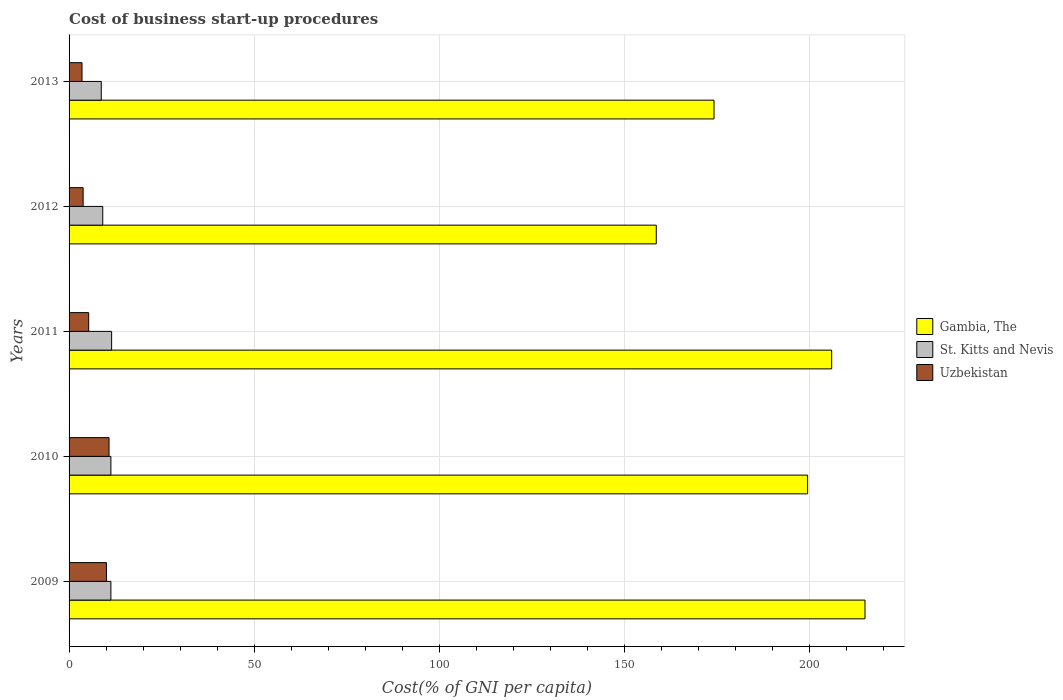How many different coloured bars are there?
Offer a terse response. 3. How many bars are there on the 1st tick from the top?
Offer a very short reply. 3. In how many cases, is the number of bars for a given year not equal to the number of legend labels?
Provide a succinct answer. 0. What is the cost of business start-up procedures in St. Kitts and Nevis in 2013?
Offer a very short reply. 8.7. Across all years, what is the maximum cost of business start-up procedures in Uzbekistan?
Give a very brief answer. 10.8. What is the total cost of business start-up procedures in Uzbekistan in the graph?
Ensure brevity in your answer.  33.5. What is the difference between the cost of business start-up procedures in Uzbekistan in 2009 and that in 2013?
Give a very brief answer. 6.6. What is the difference between the cost of business start-up procedures in Uzbekistan in 2011 and the cost of business start-up procedures in Gambia, The in 2012?
Ensure brevity in your answer.  -153.4. What is the ratio of the cost of business start-up procedures in Gambia, The in 2009 to that in 2010?
Your answer should be compact. 1.08. What is the difference between the highest and the second highest cost of business start-up procedures in Uzbekistan?
Your response must be concise. 0.7. What is the difference between the highest and the lowest cost of business start-up procedures in Uzbekistan?
Provide a succinct answer. 7.3. What does the 3rd bar from the top in 2009 represents?
Offer a very short reply. Gambia, The. What does the 1st bar from the bottom in 2011 represents?
Your response must be concise. Gambia, The. Is it the case that in every year, the sum of the cost of business start-up procedures in St. Kitts and Nevis and cost of business start-up procedures in Gambia, The is greater than the cost of business start-up procedures in Uzbekistan?
Offer a very short reply. Yes. How many bars are there?
Your answer should be compact. 15. What is the difference between two consecutive major ticks on the X-axis?
Make the answer very short. 50. Are the values on the major ticks of X-axis written in scientific E-notation?
Ensure brevity in your answer.  No. Does the graph contain grids?
Offer a terse response. Yes. Where does the legend appear in the graph?
Offer a very short reply. Center right. What is the title of the graph?
Offer a terse response. Cost of business start-up procedures. Does "High income: OECD" appear as one of the legend labels in the graph?
Your answer should be compact. No. What is the label or title of the X-axis?
Make the answer very short. Cost(% of GNI per capita). What is the Cost(% of GNI per capita) in Gambia, The in 2009?
Provide a short and direct response. 215.1. What is the Cost(% of GNI per capita) of St. Kitts and Nevis in 2009?
Your answer should be compact. 11.3. What is the Cost(% of GNI per capita) in Uzbekistan in 2009?
Provide a short and direct response. 10.1. What is the Cost(% of GNI per capita) in Gambia, The in 2010?
Offer a very short reply. 199.6. What is the Cost(% of GNI per capita) in St. Kitts and Nevis in 2010?
Provide a short and direct response. 11.3. What is the Cost(% of GNI per capita) of Uzbekistan in 2010?
Keep it short and to the point. 10.8. What is the Cost(% of GNI per capita) in Gambia, The in 2011?
Offer a terse response. 206.1. What is the Cost(% of GNI per capita) in Gambia, The in 2012?
Make the answer very short. 158.7. What is the Cost(% of GNI per capita) of St. Kitts and Nevis in 2012?
Provide a short and direct response. 9.1. What is the Cost(% of GNI per capita) of Uzbekistan in 2012?
Your response must be concise. 3.8. What is the Cost(% of GNI per capita) of Gambia, The in 2013?
Provide a short and direct response. 174.3. What is the Cost(% of GNI per capita) of St. Kitts and Nevis in 2013?
Provide a short and direct response. 8.7. What is the Cost(% of GNI per capita) in Uzbekistan in 2013?
Provide a short and direct response. 3.5. Across all years, what is the maximum Cost(% of GNI per capita) of Gambia, The?
Provide a short and direct response. 215.1. Across all years, what is the maximum Cost(% of GNI per capita) of St. Kitts and Nevis?
Ensure brevity in your answer.  11.5. Across all years, what is the maximum Cost(% of GNI per capita) in Uzbekistan?
Offer a very short reply. 10.8. Across all years, what is the minimum Cost(% of GNI per capita) of Gambia, The?
Your answer should be very brief. 158.7. Across all years, what is the minimum Cost(% of GNI per capita) in St. Kitts and Nevis?
Make the answer very short. 8.7. Across all years, what is the minimum Cost(% of GNI per capita) in Uzbekistan?
Your answer should be very brief. 3.5. What is the total Cost(% of GNI per capita) in Gambia, The in the graph?
Keep it short and to the point. 953.8. What is the total Cost(% of GNI per capita) in St. Kitts and Nevis in the graph?
Provide a succinct answer. 51.9. What is the total Cost(% of GNI per capita) in Uzbekistan in the graph?
Offer a terse response. 33.5. What is the difference between the Cost(% of GNI per capita) in Gambia, The in 2009 and that in 2010?
Your answer should be very brief. 15.5. What is the difference between the Cost(% of GNI per capita) in St. Kitts and Nevis in 2009 and that in 2010?
Offer a very short reply. 0. What is the difference between the Cost(% of GNI per capita) of St. Kitts and Nevis in 2009 and that in 2011?
Provide a succinct answer. -0.2. What is the difference between the Cost(% of GNI per capita) of Gambia, The in 2009 and that in 2012?
Give a very brief answer. 56.4. What is the difference between the Cost(% of GNI per capita) of St. Kitts and Nevis in 2009 and that in 2012?
Keep it short and to the point. 2.2. What is the difference between the Cost(% of GNI per capita) of Uzbekistan in 2009 and that in 2012?
Keep it short and to the point. 6.3. What is the difference between the Cost(% of GNI per capita) in Gambia, The in 2009 and that in 2013?
Make the answer very short. 40.8. What is the difference between the Cost(% of GNI per capita) of St. Kitts and Nevis in 2010 and that in 2011?
Ensure brevity in your answer.  -0.2. What is the difference between the Cost(% of GNI per capita) in Uzbekistan in 2010 and that in 2011?
Keep it short and to the point. 5.5. What is the difference between the Cost(% of GNI per capita) of Gambia, The in 2010 and that in 2012?
Offer a very short reply. 40.9. What is the difference between the Cost(% of GNI per capita) of Uzbekistan in 2010 and that in 2012?
Your response must be concise. 7. What is the difference between the Cost(% of GNI per capita) in Gambia, The in 2010 and that in 2013?
Your answer should be compact. 25.3. What is the difference between the Cost(% of GNI per capita) in Gambia, The in 2011 and that in 2012?
Give a very brief answer. 47.4. What is the difference between the Cost(% of GNI per capita) in St. Kitts and Nevis in 2011 and that in 2012?
Your answer should be compact. 2.4. What is the difference between the Cost(% of GNI per capita) of Uzbekistan in 2011 and that in 2012?
Offer a very short reply. 1.5. What is the difference between the Cost(% of GNI per capita) in Gambia, The in 2011 and that in 2013?
Make the answer very short. 31.8. What is the difference between the Cost(% of GNI per capita) in Gambia, The in 2012 and that in 2013?
Provide a succinct answer. -15.6. What is the difference between the Cost(% of GNI per capita) of Gambia, The in 2009 and the Cost(% of GNI per capita) of St. Kitts and Nevis in 2010?
Provide a succinct answer. 203.8. What is the difference between the Cost(% of GNI per capita) in Gambia, The in 2009 and the Cost(% of GNI per capita) in Uzbekistan in 2010?
Provide a short and direct response. 204.3. What is the difference between the Cost(% of GNI per capita) of Gambia, The in 2009 and the Cost(% of GNI per capita) of St. Kitts and Nevis in 2011?
Provide a succinct answer. 203.6. What is the difference between the Cost(% of GNI per capita) of Gambia, The in 2009 and the Cost(% of GNI per capita) of Uzbekistan in 2011?
Make the answer very short. 209.8. What is the difference between the Cost(% of GNI per capita) of St. Kitts and Nevis in 2009 and the Cost(% of GNI per capita) of Uzbekistan in 2011?
Your answer should be compact. 6. What is the difference between the Cost(% of GNI per capita) of Gambia, The in 2009 and the Cost(% of GNI per capita) of St. Kitts and Nevis in 2012?
Keep it short and to the point. 206. What is the difference between the Cost(% of GNI per capita) in Gambia, The in 2009 and the Cost(% of GNI per capita) in Uzbekistan in 2012?
Your answer should be very brief. 211.3. What is the difference between the Cost(% of GNI per capita) in St. Kitts and Nevis in 2009 and the Cost(% of GNI per capita) in Uzbekistan in 2012?
Provide a short and direct response. 7.5. What is the difference between the Cost(% of GNI per capita) of Gambia, The in 2009 and the Cost(% of GNI per capita) of St. Kitts and Nevis in 2013?
Ensure brevity in your answer.  206.4. What is the difference between the Cost(% of GNI per capita) in Gambia, The in 2009 and the Cost(% of GNI per capita) in Uzbekistan in 2013?
Give a very brief answer. 211.6. What is the difference between the Cost(% of GNI per capita) in Gambia, The in 2010 and the Cost(% of GNI per capita) in St. Kitts and Nevis in 2011?
Give a very brief answer. 188.1. What is the difference between the Cost(% of GNI per capita) in Gambia, The in 2010 and the Cost(% of GNI per capita) in Uzbekistan in 2011?
Give a very brief answer. 194.3. What is the difference between the Cost(% of GNI per capita) in Gambia, The in 2010 and the Cost(% of GNI per capita) in St. Kitts and Nevis in 2012?
Offer a terse response. 190.5. What is the difference between the Cost(% of GNI per capita) of Gambia, The in 2010 and the Cost(% of GNI per capita) of Uzbekistan in 2012?
Offer a terse response. 195.8. What is the difference between the Cost(% of GNI per capita) in St. Kitts and Nevis in 2010 and the Cost(% of GNI per capita) in Uzbekistan in 2012?
Give a very brief answer. 7.5. What is the difference between the Cost(% of GNI per capita) of Gambia, The in 2010 and the Cost(% of GNI per capita) of St. Kitts and Nevis in 2013?
Your answer should be compact. 190.9. What is the difference between the Cost(% of GNI per capita) of Gambia, The in 2010 and the Cost(% of GNI per capita) of Uzbekistan in 2013?
Your answer should be compact. 196.1. What is the difference between the Cost(% of GNI per capita) of Gambia, The in 2011 and the Cost(% of GNI per capita) of St. Kitts and Nevis in 2012?
Provide a short and direct response. 197. What is the difference between the Cost(% of GNI per capita) of Gambia, The in 2011 and the Cost(% of GNI per capita) of Uzbekistan in 2012?
Make the answer very short. 202.3. What is the difference between the Cost(% of GNI per capita) of St. Kitts and Nevis in 2011 and the Cost(% of GNI per capita) of Uzbekistan in 2012?
Your response must be concise. 7.7. What is the difference between the Cost(% of GNI per capita) of Gambia, The in 2011 and the Cost(% of GNI per capita) of St. Kitts and Nevis in 2013?
Provide a short and direct response. 197.4. What is the difference between the Cost(% of GNI per capita) of Gambia, The in 2011 and the Cost(% of GNI per capita) of Uzbekistan in 2013?
Give a very brief answer. 202.6. What is the difference between the Cost(% of GNI per capita) of Gambia, The in 2012 and the Cost(% of GNI per capita) of St. Kitts and Nevis in 2013?
Ensure brevity in your answer.  150. What is the difference between the Cost(% of GNI per capita) in Gambia, The in 2012 and the Cost(% of GNI per capita) in Uzbekistan in 2013?
Provide a short and direct response. 155.2. What is the difference between the Cost(% of GNI per capita) of St. Kitts and Nevis in 2012 and the Cost(% of GNI per capita) of Uzbekistan in 2013?
Keep it short and to the point. 5.6. What is the average Cost(% of GNI per capita) in Gambia, The per year?
Keep it short and to the point. 190.76. What is the average Cost(% of GNI per capita) of St. Kitts and Nevis per year?
Make the answer very short. 10.38. In the year 2009, what is the difference between the Cost(% of GNI per capita) in Gambia, The and Cost(% of GNI per capita) in St. Kitts and Nevis?
Offer a terse response. 203.8. In the year 2009, what is the difference between the Cost(% of GNI per capita) in Gambia, The and Cost(% of GNI per capita) in Uzbekistan?
Give a very brief answer. 205. In the year 2010, what is the difference between the Cost(% of GNI per capita) of Gambia, The and Cost(% of GNI per capita) of St. Kitts and Nevis?
Your answer should be very brief. 188.3. In the year 2010, what is the difference between the Cost(% of GNI per capita) of Gambia, The and Cost(% of GNI per capita) of Uzbekistan?
Provide a short and direct response. 188.8. In the year 2011, what is the difference between the Cost(% of GNI per capita) of Gambia, The and Cost(% of GNI per capita) of St. Kitts and Nevis?
Provide a succinct answer. 194.6. In the year 2011, what is the difference between the Cost(% of GNI per capita) in Gambia, The and Cost(% of GNI per capita) in Uzbekistan?
Ensure brevity in your answer.  200.8. In the year 2011, what is the difference between the Cost(% of GNI per capita) of St. Kitts and Nevis and Cost(% of GNI per capita) of Uzbekistan?
Provide a succinct answer. 6.2. In the year 2012, what is the difference between the Cost(% of GNI per capita) of Gambia, The and Cost(% of GNI per capita) of St. Kitts and Nevis?
Your response must be concise. 149.6. In the year 2012, what is the difference between the Cost(% of GNI per capita) in Gambia, The and Cost(% of GNI per capita) in Uzbekistan?
Offer a terse response. 154.9. In the year 2013, what is the difference between the Cost(% of GNI per capita) of Gambia, The and Cost(% of GNI per capita) of St. Kitts and Nevis?
Your response must be concise. 165.6. In the year 2013, what is the difference between the Cost(% of GNI per capita) in Gambia, The and Cost(% of GNI per capita) in Uzbekistan?
Provide a succinct answer. 170.8. What is the ratio of the Cost(% of GNI per capita) in Gambia, The in 2009 to that in 2010?
Keep it short and to the point. 1.08. What is the ratio of the Cost(% of GNI per capita) of Uzbekistan in 2009 to that in 2010?
Offer a terse response. 0.94. What is the ratio of the Cost(% of GNI per capita) in Gambia, The in 2009 to that in 2011?
Your response must be concise. 1.04. What is the ratio of the Cost(% of GNI per capita) of St. Kitts and Nevis in 2009 to that in 2011?
Keep it short and to the point. 0.98. What is the ratio of the Cost(% of GNI per capita) in Uzbekistan in 2009 to that in 2011?
Your response must be concise. 1.91. What is the ratio of the Cost(% of GNI per capita) in Gambia, The in 2009 to that in 2012?
Offer a terse response. 1.36. What is the ratio of the Cost(% of GNI per capita) of St. Kitts and Nevis in 2009 to that in 2012?
Offer a very short reply. 1.24. What is the ratio of the Cost(% of GNI per capita) in Uzbekistan in 2009 to that in 2012?
Offer a very short reply. 2.66. What is the ratio of the Cost(% of GNI per capita) of Gambia, The in 2009 to that in 2013?
Offer a very short reply. 1.23. What is the ratio of the Cost(% of GNI per capita) of St. Kitts and Nevis in 2009 to that in 2013?
Make the answer very short. 1.3. What is the ratio of the Cost(% of GNI per capita) of Uzbekistan in 2009 to that in 2013?
Offer a very short reply. 2.89. What is the ratio of the Cost(% of GNI per capita) in Gambia, The in 2010 to that in 2011?
Make the answer very short. 0.97. What is the ratio of the Cost(% of GNI per capita) of St. Kitts and Nevis in 2010 to that in 2011?
Your answer should be very brief. 0.98. What is the ratio of the Cost(% of GNI per capita) of Uzbekistan in 2010 to that in 2011?
Give a very brief answer. 2.04. What is the ratio of the Cost(% of GNI per capita) in Gambia, The in 2010 to that in 2012?
Offer a terse response. 1.26. What is the ratio of the Cost(% of GNI per capita) of St. Kitts and Nevis in 2010 to that in 2012?
Keep it short and to the point. 1.24. What is the ratio of the Cost(% of GNI per capita) of Uzbekistan in 2010 to that in 2012?
Offer a terse response. 2.84. What is the ratio of the Cost(% of GNI per capita) in Gambia, The in 2010 to that in 2013?
Make the answer very short. 1.15. What is the ratio of the Cost(% of GNI per capita) of St. Kitts and Nevis in 2010 to that in 2013?
Offer a very short reply. 1.3. What is the ratio of the Cost(% of GNI per capita) of Uzbekistan in 2010 to that in 2013?
Provide a short and direct response. 3.09. What is the ratio of the Cost(% of GNI per capita) of Gambia, The in 2011 to that in 2012?
Keep it short and to the point. 1.3. What is the ratio of the Cost(% of GNI per capita) of St. Kitts and Nevis in 2011 to that in 2012?
Provide a succinct answer. 1.26. What is the ratio of the Cost(% of GNI per capita) of Uzbekistan in 2011 to that in 2012?
Keep it short and to the point. 1.39. What is the ratio of the Cost(% of GNI per capita) in Gambia, The in 2011 to that in 2013?
Make the answer very short. 1.18. What is the ratio of the Cost(% of GNI per capita) of St. Kitts and Nevis in 2011 to that in 2013?
Make the answer very short. 1.32. What is the ratio of the Cost(% of GNI per capita) of Uzbekistan in 2011 to that in 2013?
Your answer should be compact. 1.51. What is the ratio of the Cost(% of GNI per capita) of Gambia, The in 2012 to that in 2013?
Provide a succinct answer. 0.91. What is the ratio of the Cost(% of GNI per capita) in St. Kitts and Nevis in 2012 to that in 2013?
Offer a very short reply. 1.05. What is the ratio of the Cost(% of GNI per capita) in Uzbekistan in 2012 to that in 2013?
Give a very brief answer. 1.09. What is the difference between the highest and the second highest Cost(% of GNI per capita) in Gambia, The?
Your response must be concise. 9. What is the difference between the highest and the second highest Cost(% of GNI per capita) of Uzbekistan?
Your answer should be very brief. 0.7. What is the difference between the highest and the lowest Cost(% of GNI per capita) of Gambia, The?
Ensure brevity in your answer.  56.4. What is the difference between the highest and the lowest Cost(% of GNI per capita) of St. Kitts and Nevis?
Make the answer very short. 2.8. 